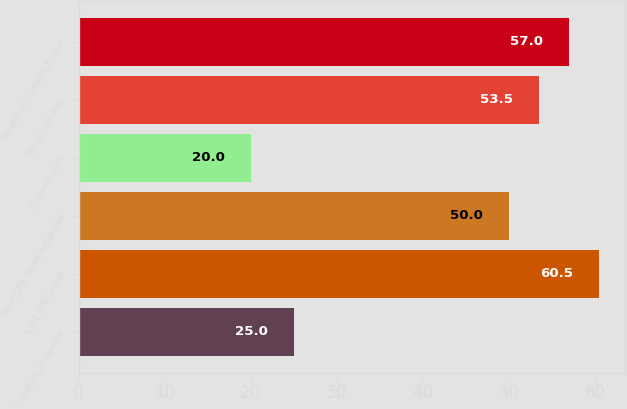Convert chart. <chart><loc_0><loc_0><loc_500><loc_500><bar_chart><fcel>330 Madison Avenue<fcel>1101 17th Street<fcel>West 57th Street properties<fcel>Fairfax Square<fcel>Monmouth Mall<fcel>Downtown Crossing Boston<nl><fcel>25<fcel>60.5<fcel>50<fcel>20<fcel>53.5<fcel>57<nl></chart> 